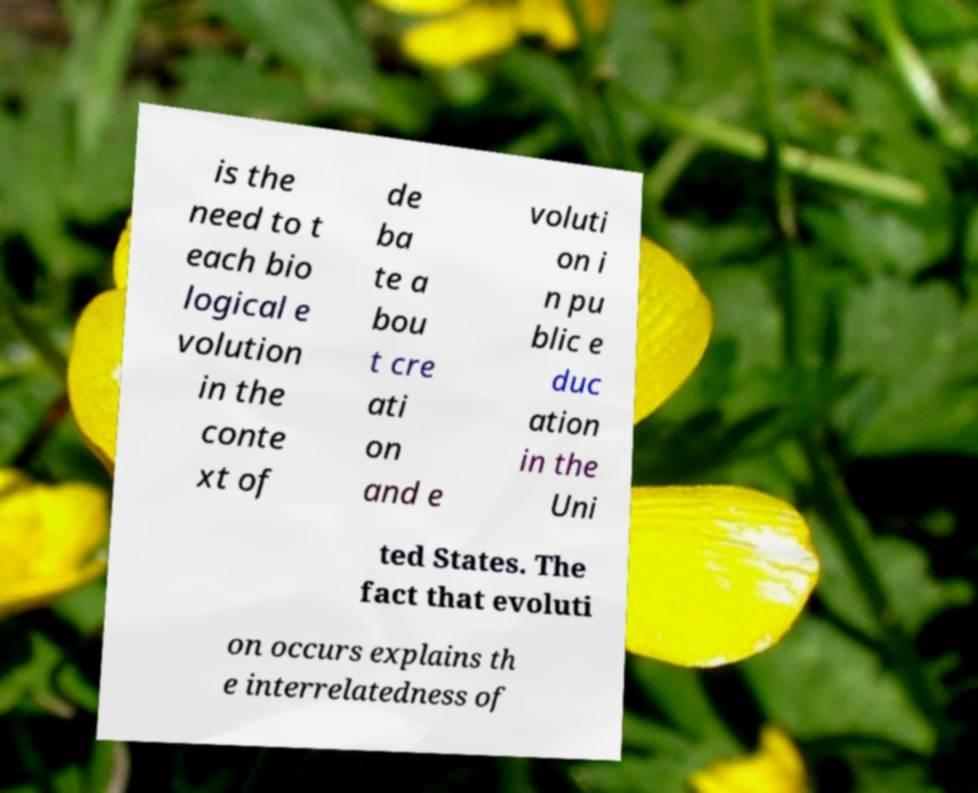For documentation purposes, I need the text within this image transcribed. Could you provide that? is the need to t each bio logical e volution in the conte xt of de ba te a bou t cre ati on and e voluti on i n pu blic e duc ation in the Uni ted States. The fact that evoluti on occurs explains th e interrelatedness of 